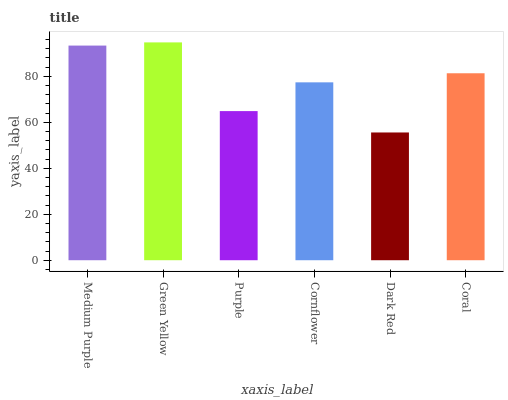Is Purple the minimum?
Answer yes or no. No. Is Purple the maximum?
Answer yes or no. No. Is Green Yellow greater than Purple?
Answer yes or no. Yes. Is Purple less than Green Yellow?
Answer yes or no. Yes. Is Purple greater than Green Yellow?
Answer yes or no. No. Is Green Yellow less than Purple?
Answer yes or no. No. Is Coral the high median?
Answer yes or no. Yes. Is Cornflower the low median?
Answer yes or no. Yes. Is Medium Purple the high median?
Answer yes or no. No. Is Purple the low median?
Answer yes or no. No. 